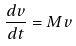<formula> <loc_0><loc_0><loc_500><loc_500>\frac { d v } { d t } = M v</formula> 